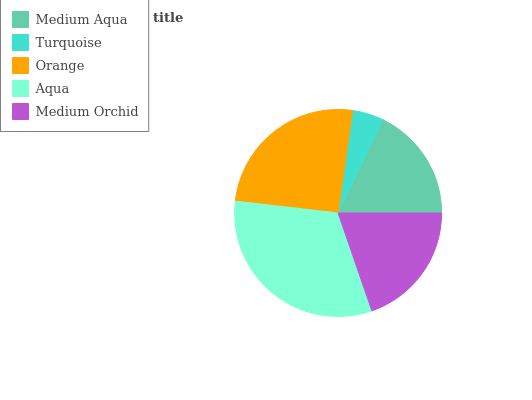Is Turquoise the minimum?
Answer yes or no. Yes. Is Aqua the maximum?
Answer yes or no. Yes. Is Orange the minimum?
Answer yes or no. No. Is Orange the maximum?
Answer yes or no. No. Is Orange greater than Turquoise?
Answer yes or no. Yes. Is Turquoise less than Orange?
Answer yes or no. Yes. Is Turquoise greater than Orange?
Answer yes or no. No. Is Orange less than Turquoise?
Answer yes or no. No. Is Medium Orchid the high median?
Answer yes or no. Yes. Is Medium Orchid the low median?
Answer yes or no. Yes. Is Turquoise the high median?
Answer yes or no. No. Is Medium Aqua the low median?
Answer yes or no. No. 